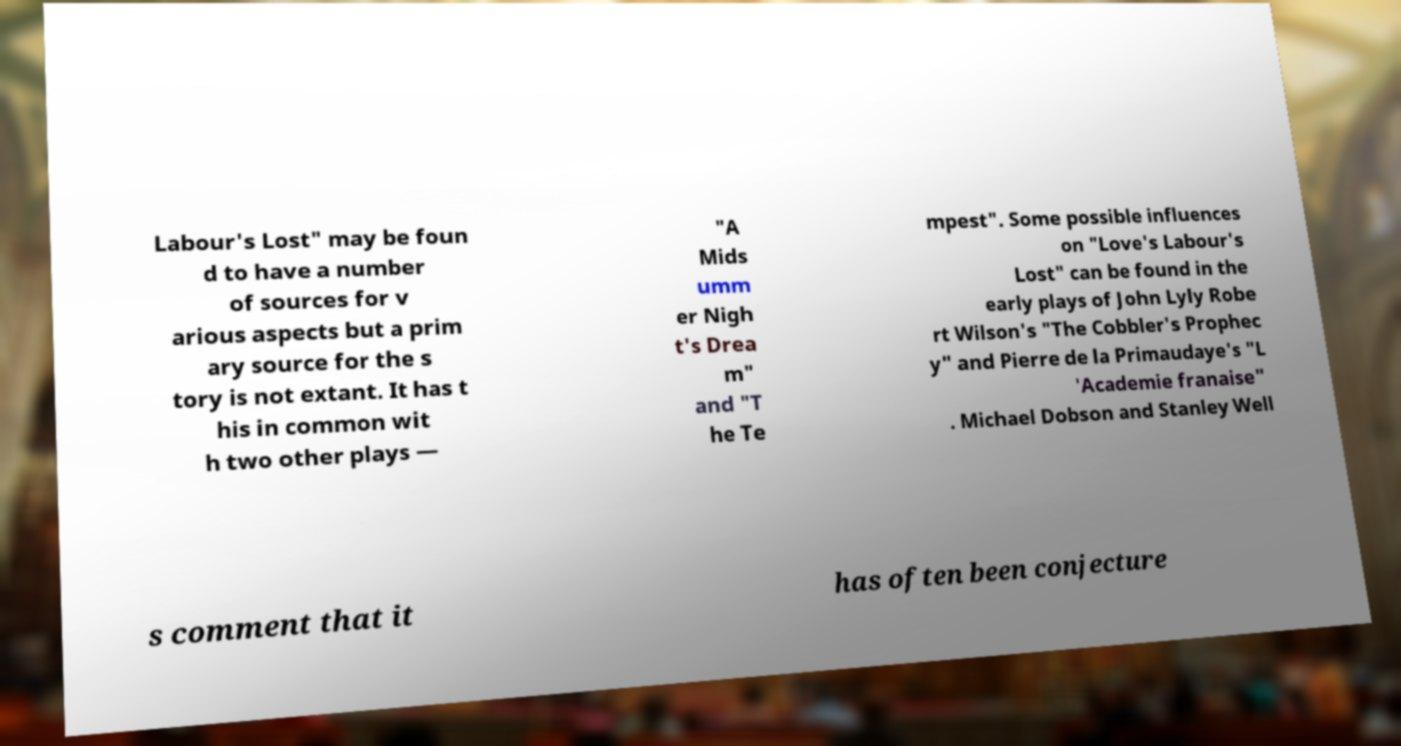Can you read and provide the text displayed in the image?This photo seems to have some interesting text. Can you extract and type it out for me? Labour's Lost" may be foun d to have a number of sources for v arious aspects but a prim ary source for the s tory is not extant. It has t his in common wit h two other plays — "A Mids umm er Nigh t's Drea m" and "T he Te mpest". Some possible influences on "Love's Labour's Lost" can be found in the early plays of John Lyly Robe rt Wilson's "The Cobbler's Prophec y" and Pierre de la Primaudaye's "L 'Academie franaise" . Michael Dobson and Stanley Well s comment that it has often been conjecture 